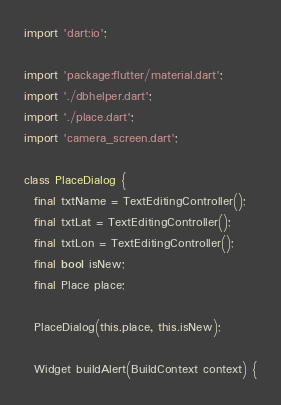<code> <loc_0><loc_0><loc_500><loc_500><_Dart_>import 'dart:io';

import 'package:flutter/material.dart';
import './dbhelper.dart';
import './place.dart';
import 'camera_screen.dart';

class PlaceDialog {
  final txtName = TextEditingController();
  final txtLat = TextEditingController();
  final txtLon = TextEditingController();
  final bool isNew;
  final Place place;

  PlaceDialog(this.place, this.isNew);

  Widget buildAlert(BuildContext context) {</code> 